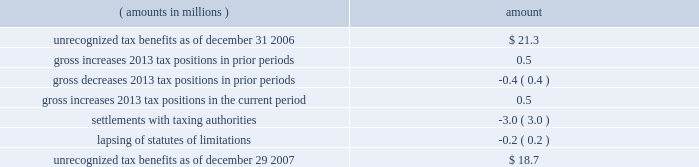Notes to consolidated financial statements ( continued ) | 72 snap-on incorporated following is a reconciliation of the beginning and ending amount of unrecognized tax benefits : ( amounts in millions ) amount .
Of the $ 18.7 million of unrecognized tax benefits at the end of 2007 , approximately $ 16.2 million would impact the effective income tax rate if recognized .
Interest and penalties related to unrecognized tax benefits are recorded in income tax expense .
During the years ended december 29 , 2007 , december 30 , 2006 , and december 31 , 2005 , the company recognized approximately $ 1.2 million , $ 0.5 million and ( $ 0.5 ) million in net interest expense ( benefit ) , respectively .
The company has provided for approximately $ 3.4 million , $ 2.2 million , and $ 1.7 million of accrued interest related to unrecognized tax benefits at the end of fiscal year 2007 , 2006 and 2005 , respectively .
During the next 12 months , the company does not anticipate any significant changes to the total amount of unrecognized tax benefits , other than the accrual of additional interest expense in an amount similar to the prior year 2019s expense .
With few exceptions , snap-on is no longer subject to u.s .
Federal and state/local income tax examinations by tax authorities for years prior to 2003 , and snap-on is no longer subject to non-u.s .
Income tax examinations by tax authorities for years prior to 2001 .
The undistributed earnings of all non-u.s .
Subsidiaries totaled $ 338.5 million , $ 247.4 million and $ 173.6 million at the end of fiscal 2007 , 2006 and 2005 , respectively .
Snap-on has not provided any deferred taxes on these undistributed earnings as it considers the undistributed earnings to be permanently invested .
Determination of the amount of unrecognized deferred income tax liability related to these earnings is not practicable .
The american jobs creation act of 2004 ( the 201cajca 201d ) created a one-time tax incentive for u.s .
Corporations to repatriate accumulated foreign earnings by providing a tax deduction of 85% ( 85 % ) of qualifying dividends received from foreign affiliates .
Under the provisions of the ajca , snap-on repatriated approximately $ 93 million of qualifying dividends in 2005 that resulted in additional income tax expense of $ 3.3 million for the year .
Note 9 : short-term and long-term debt notes payable and long-term debt as of december 29 , 2007 , was $ 517.9 million ; no commercial paper was outstanding at december 29 , 2007 .
As of december 30 , 2006 , notes payable and long-term debt was $ 549.2 million , including $ 314.9 million of commercial paper .
Snap-on presented $ 300 million of the december 30 , 2006 , outstanding commercial paper as 201clong-term debt 201d on the accompanying december 30 , 2006 , consolidated balance sheet .
On january 12 , 2007 , snap-on sold $ 300 million of unsecured notes consisting of $ 150 million of floating rate notes that mature on january 12 , 2010 , and $ 150 million of fixed rate notes that mature on january 15 , 2017 .
Interest on the floating rate notes accrues at a rate equal to the three-month london interbank offer rate plus 0.13% ( 0.13 % ) per year and is payable quarterly .
Interest on the fixed rate notes accrues at a rate of 5.50% ( 5.50 % ) per year and is payable semi-annually .
Snap-on used the proceeds from the sale of the notes , net of $ 1.5 million of transaction costs , to repay commercial paper obligations issued to finance the acquisition of business solutions .
On january 12 , 2007 , the company also terminated a $ 250 million bridge credit agreement that snap-on established prior to its acquisition of business solutions. .
What is the net change amount in the balance of unrecognized tax benefits from 2006 to 2007? 
Computations: (18.7 - 21.3)
Answer: -2.6. 